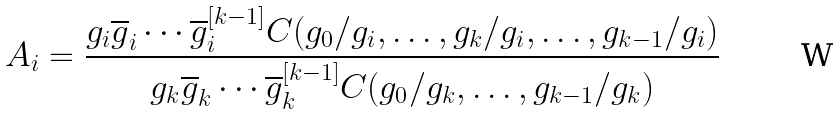Convert formula to latex. <formula><loc_0><loc_0><loc_500><loc_500>A _ { i } = \frac { g _ { i } \overline { g } _ { i } \cdots \overline { g } ^ { [ k - 1 ] } _ { i } C ( g _ { 0 } / g _ { i } , \dots , g _ { k } / g _ { i } , \dots , g _ { k - 1 } / g _ { i } ) } { g _ { k } \overline { g } _ { k } \cdots \overline { g } ^ { [ k - 1 ] } _ { k } C ( g _ { 0 } / g _ { k } , \dots , g _ { k - 1 } / g _ { k } ) }</formula> 